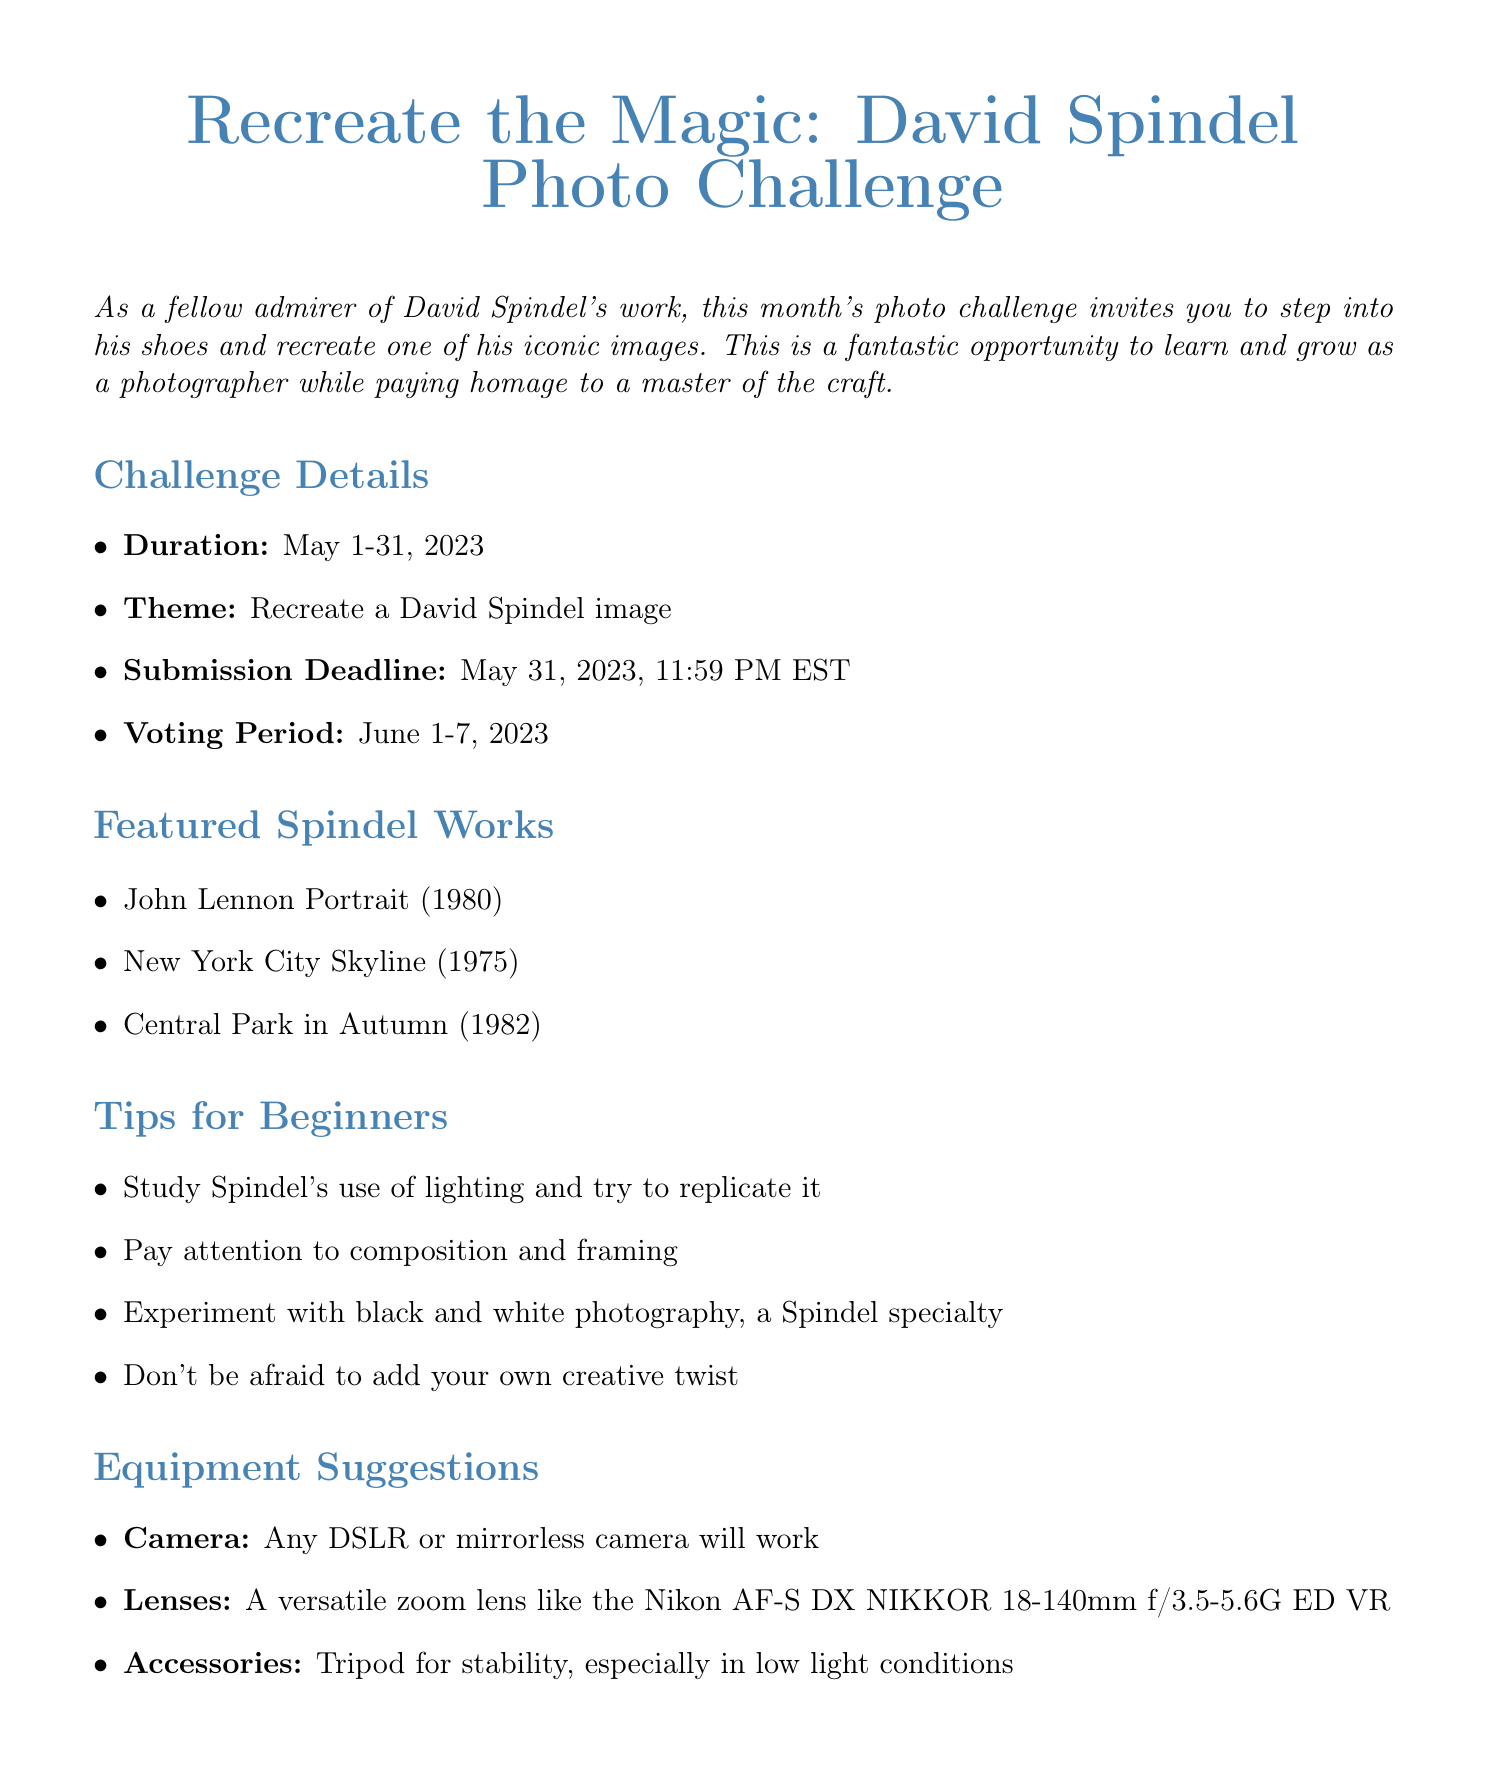What is the duration of the photo challenge? The duration of the photo challenge is specified as May 1-31, 2023.
Answer: May 1-31, 2023 What are the submission guidelines? The submission guidelines include format, required information, and the submission platform outlined in the document.
Answer: JPEG, maximum 5MB file size Who is the featured participant in the community spotlight? The community spotlight section mentions the featured participant by name along with a quote about their experience.
Answer: Sarah Chen What is the first-place prize for the challenge? The prizes section states the awards for the winners with specific details for each place.
Answer: A signed print by David Spindel Which software is recommended for post-processing? The post-processing tips highlight software options suitable for beginners to enhance their images.
Answer: Adobe Lightroom or Capture One What is the theme of this photo challenge? The document clearly states the central theme around which the challenge is based.
Answer: Recreate a David Spindel image What is the voting period for the challenge? The document specifies the timeframe during which community voting will take place after submissions are made.
Answer: June 1-7, 2023 What are the criteria for voting? The voting process section outlines the key aspects that participants need to consider when voting on submissions.
Answer: Creativity in interpretation, Technical execution, Capture of Spindel's essence 